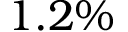Convert formula to latex. <formula><loc_0><loc_0><loc_500><loc_500>1 . 2 \%</formula> 